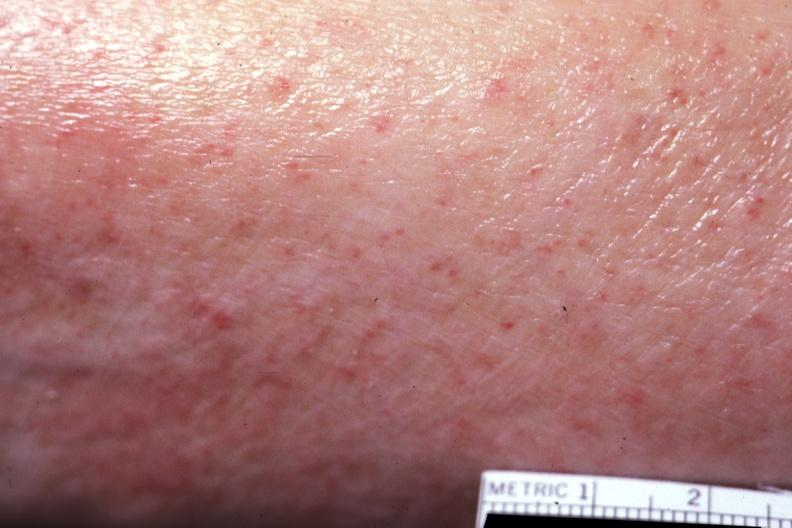does this image show close-up well shown?
Answer the question using a single word or phrase. Yes 